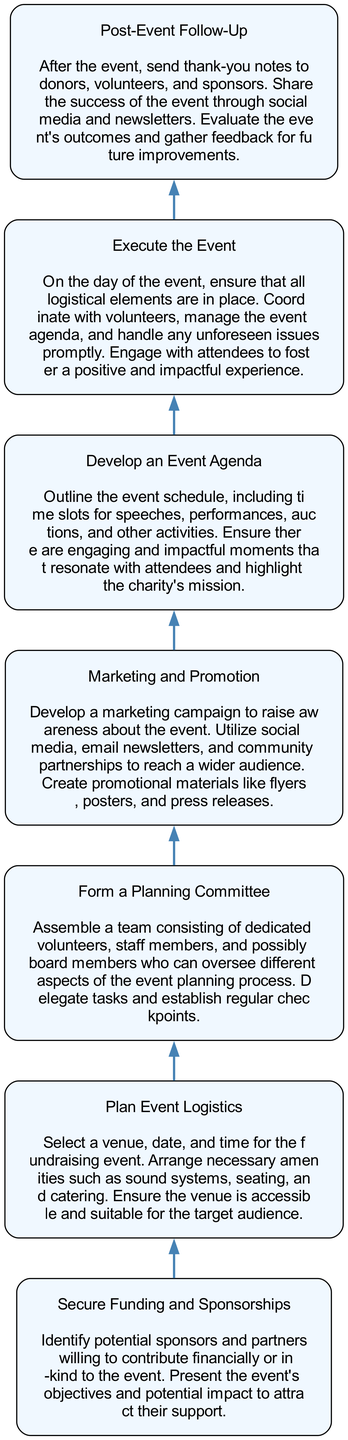what is the starting step of the flowchart? The starting step is the initial node, which is "Secure Funding and Sponsorships", indicating the first action to take in conducting a successful fundraising event.
Answer: Secure Funding and Sponsorships how many steps are there in total? By counting the individual nodes listed in the diagram, we find there are seven distinct steps outlined for the fundraising event process.
Answer: 7 what is the last step in the process? The last step in the flowchart is "Post-Event Follow-Up", which is necessary to ensure proper closure and engagement with event stakeholders after the event concludes.
Answer: Post-Event Follow-Up which step comes immediately after "Marketing and Promotion"? The flow of the diagram indicates that the step that follows "Marketing and Promotion" is "Develop an Event Agenda", signifying the progression of tasks to be executed for the event.
Answer: Develop an Event Agenda what is the focus of the "Plan Event Logistics" step? This step emphasizes organizing the practical aspects of the event, like venue selection and necessary amenities to ensure the event runs smoothly.
Answer: Select a venue, date, and time which steps involve securing support from others? Both "Secure Funding and Sponsorships" and "Form a Planning Committee" require collaboration and support from sponsors, partners, team members, and volunteers, illustrating the importance of community engagement.
Answer: Secure Funding and Sponsorships; Form a Planning Committee what role does "Execute the Event" play in the overall process? The "Execute the Event" step is crucial as it involves the actual implementation of the planning, requiring coordination and management on the event day to ensure all goes as planned.
Answer: Implementation of the planning what action should be taken after the event according to the diagram? The diagram clearly states that following the event, the vital action is to conduct a "Post-Event Follow-Up", which includes sending thank-you notes and evaluating the event’s outcomes.
Answer: Post-Event Follow-Up 